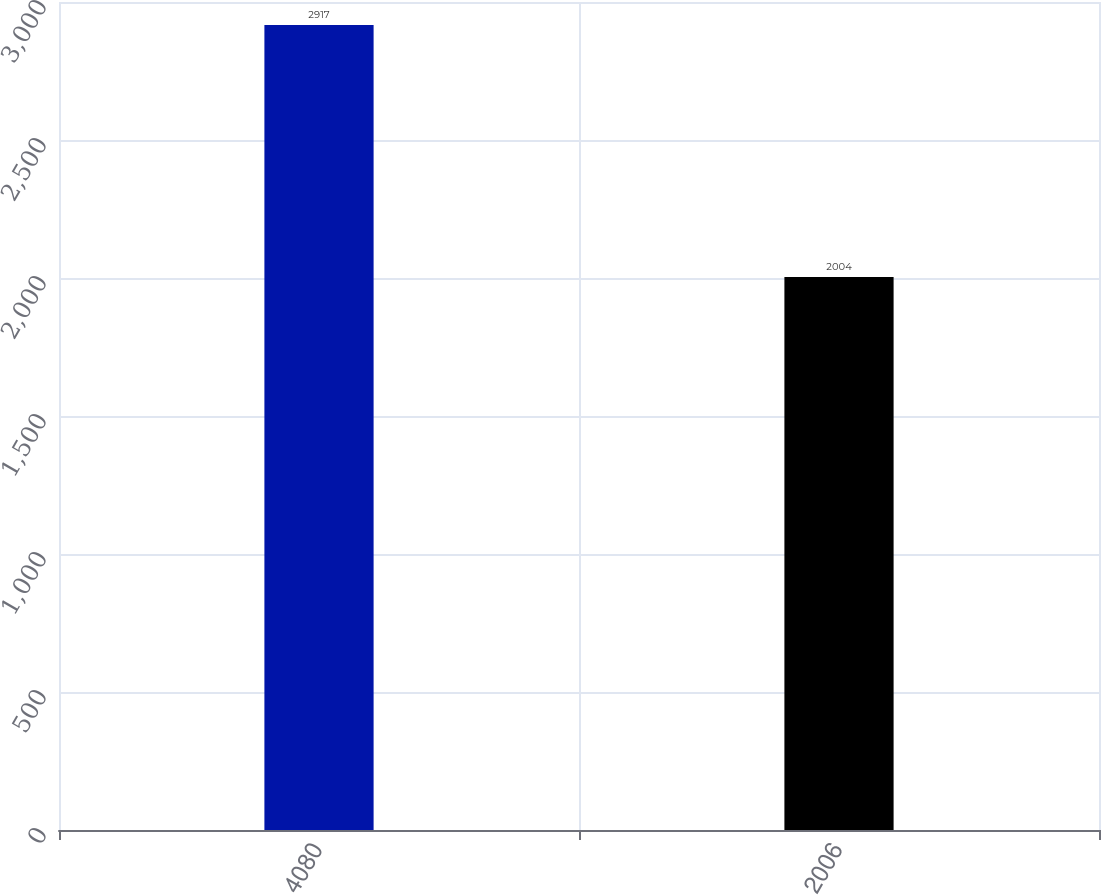Convert chart to OTSL. <chart><loc_0><loc_0><loc_500><loc_500><bar_chart><fcel>4080<fcel>2006<nl><fcel>2917<fcel>2004<nl></chart> 